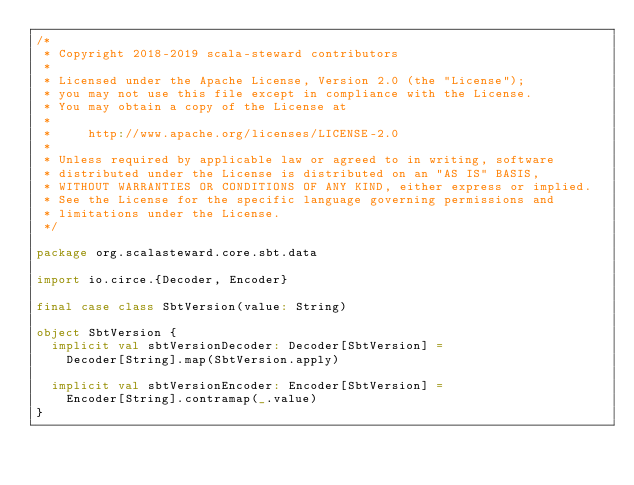Convert code to text. <code><loc_0><loc_0><loc_500><loc_500><_Scala_>/*
 * Copyright 2018-2019 scala-steward contributors
 *
 * Licensed under the Apache License, Version 2.0 (the "License");
 * you may not use this file except in compliance with the License.
 * You may obtain a copy of the License at
 *
 *     http://www.apache.org/licenses/LICENSE-2.0
 *
 * Unless required by applicable law or agreed to in writing, software
 * distributed under the License is distributed on an "AS IS" BASIS,
 * WITHOUT WARRANTIES OR CONDITIONS OF ANY KIND, either express or implied.
 * See the License for the specific language governing permissions and
 * limitations under the License.
 */

package org.scalasteward.core.sbt.data

import io.circe.{Decoder, Encoder}

final case class SbtVersion(value: String)

object SbtVersion {
  implicit val sbtVersionDecoder: Decoder[SbtVersion] =
    Decoder[String].map(SbtVersion.apply)

  implicit val sbtVersionEncoder: Encoder[SbtVersion] =
    Encoder[String].contramap(_.value)
}
</code> 